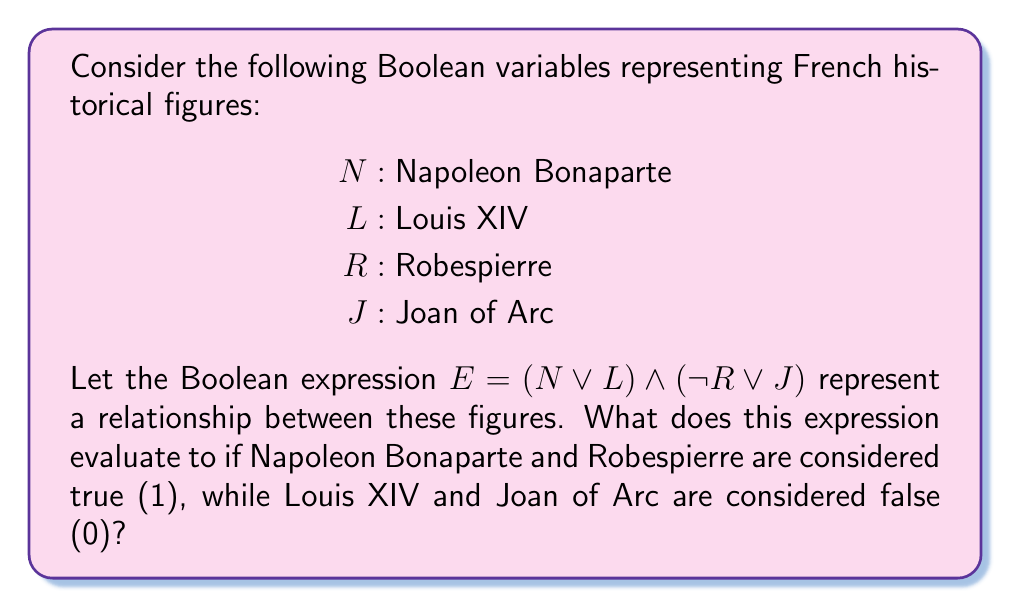Help me with this question. Let's approach this step-by-step:

1) First, let's substitute the given values into our expression:
   $E = (N \lor L) \land (\lnot R \lor J)$
   $E = (1 \lor 0) \land (\lnot 1 \lor 0)$

2) Now, let's evaluate the expressions within the parentheses:
   a) $(1 \lor 0) = 1$ (OR operation: true if at least one is true)
   b) $(\lnot 1 \lor 0)$:
      - $\lnot 1 = 0$ (NOT operation: inverts the value)
      - $(0 \lor 0) = 0$ (OR operation: false if both are false)

3) Our expression now looks like this:
   $E = 1 \land 0$

4) Finally, we perform the AND operation:
   $1 \land 0 = 0$ (AND operation: false if at least one is false)

Therefore, the expression evaluates to 0 (false).
Answer: 0 